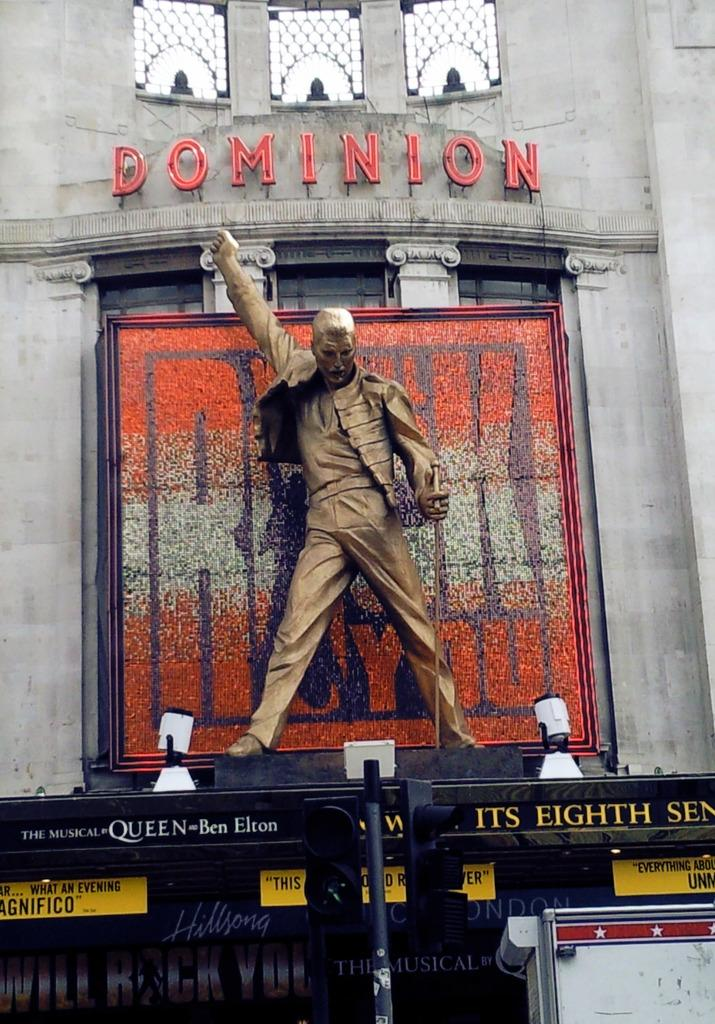Provide a one-sentence caption for the provided image. A statue of Freddy Mercury in full flow stands atop the entrance of the Dominican Theatre in London. 